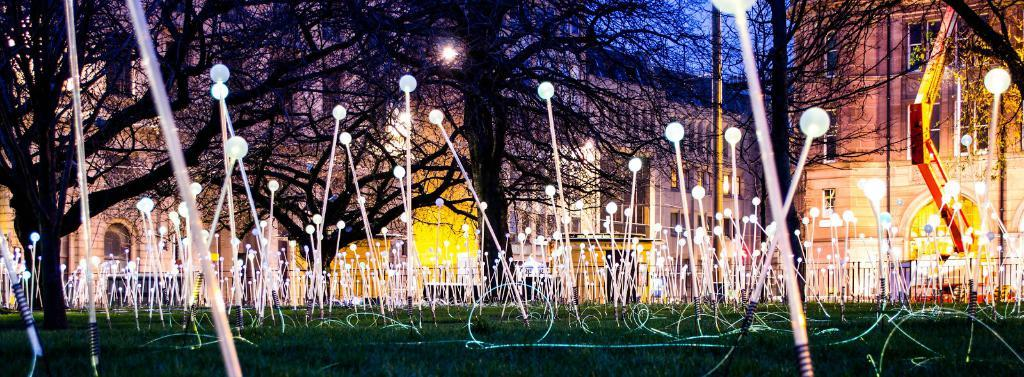What type of vegetation is present on the ground in the image? There is grass on the ground in the image. What can be seen illuminating the scene in the image? There are lights visible in the image. What type of natural features are present in the image? There are trees in the image. What type of man-made structures are present in the image? There are buildings in the image. What type of plough is being used to cultivate the grass in the image? There is no plough present in the image; it features grass, lights, trees, and buildings. What is the credit score of the person in the image? There is no person present in the image, so it is not possible to determine their credit score. 